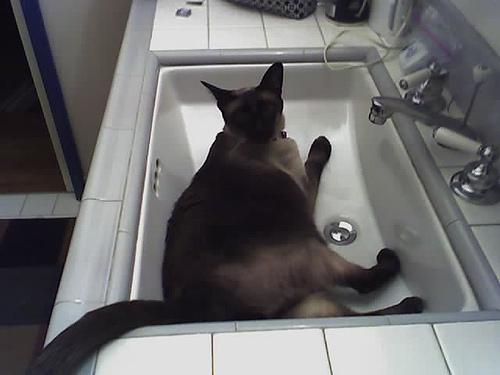What is the cat sitting in?
Short answer required. Sink. Who is in the sink?
Write a very short answer. Cat. Is that a short-haired cat?
Quick response, please. Yes. What is this cat climbing out of?
Be succinct. Sink. Does this animal look comfortable?
Be succinct. Yes. 